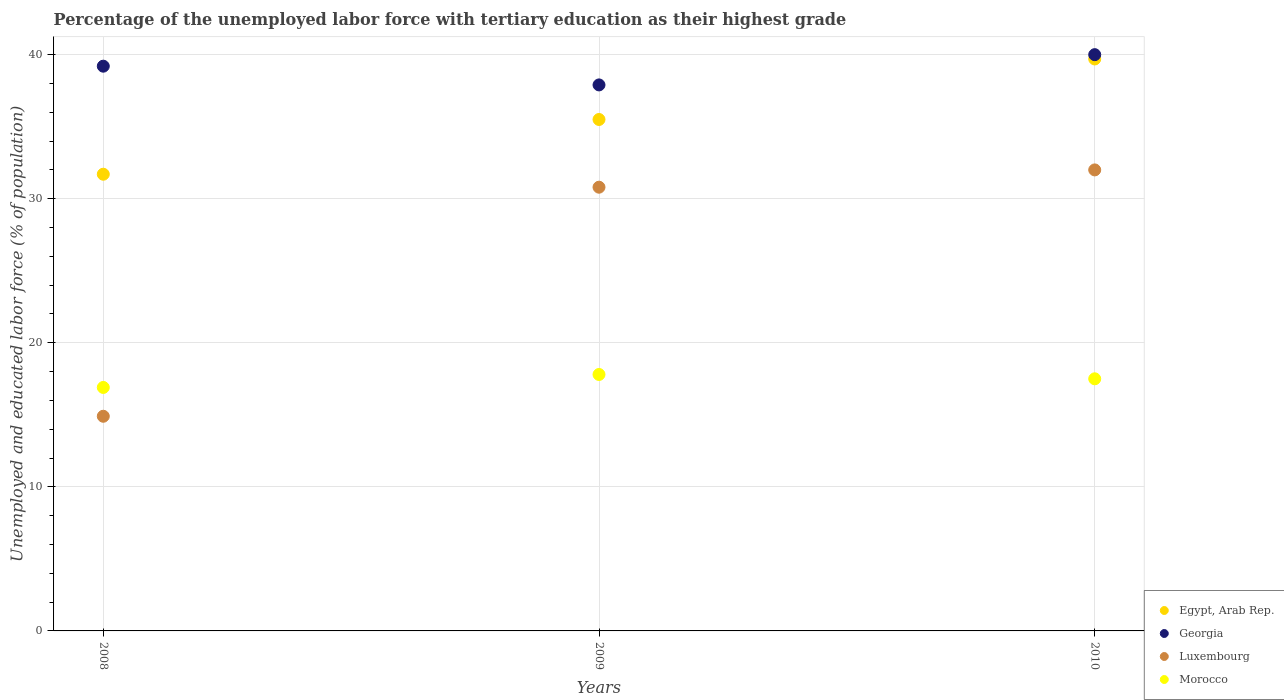Is the number of dotlines equal to the number of legend labels?
Offer a terse response. Yes. What is the percentage of the unemployed labor force with tertiary education in Egypt, Arab Rep. in 2009?
Your answer should be very brief. 35.5. Across all years, what is the maximum percentage of the unemployed labor force with tertiary education in Egypt, Arab Rep.?
Offer a very short reply. 39.7. Across all years, what is the minimum percentage of the unemployed labor force with tertiary education in Morocco?
Make the answer very short. 16.9. In which year was the percentage of the unemployed labor force with tertiary education in Morocco maximum?
Give a very brief answer. 2009. In which year was the percentage of the unemployed labor force with tertiary education in Morocco minimum?
Provide a short and direct response. 2008. What is the total percentage of the unemployed labor force with tertiary education in Luxembourg in the graph?
Provide a succinct answer. 77.7. What is the difference between the percentage of the unemployed labor force with tertiary education in Egypt, Arab Rep. in 2008 and that in 2010?
Give a very brief answer. -8. What is the difference between the percentage of the unemployed labor force with tertiary education in Georgia in 2008 and the percentage of the unemployed labor force with tertiary education in Morocco in 2010?
Offer a very short reply. 21.7. What is the average percentage of the unemployed labor force with tertiary education in Georgia per year?
Offer a very short reply. 39.03. In the year 2008, what is the difference between the percentage of the unemployed labor force with tertiary education in Morocco and percentage of the unemployed labor force with tertiary education in Egypt, Arab Rep.?
Make the answer very short. -14.8. In how many years, is the percentage of the unemployed labor force with tertiary education in Georgia greater than 32 %?
Your answer should be compact. 3. What is the ratio of the percentage of the unemployed labor force with tertiary education in Morocco in 2008 to that in 2009?
Your response must be concise. 0.95. Is the difference between the percentage of the unemployed labor force with tertiary education in Morocco in 2009 and 2010 greater than the difference between the percentage of the unemployed labor force with tertiary education in Egypt, Arab Rep. in 2009 and 2010?
Ensure brevity in your answer.  Yes. What is the difference between the highest and the second highest percentage of the unemployed labor force with tertiary education in Egypt, Arab Rep.?
Provide a succinct answer. 4.2. What is the difference between the highest and the lowest percentage of the unemployed labor force with tertiary education in Georgia?
Your answer should be compact. 2.1. In how many years, is the percentage of the unemployed labor force with tertiary education in Egypt, Arab Rep. greater than the average percentage of the unemployed labor force with tertiary education in Egypt, Arab Rep. taken over all years?
Your response must be concise. 1. Is the sum of the percentage of the unemployed labor force with tertiary education in Morocco in 2008 and 2010 greater than the maximum percentage of the unemployed labor force with tertiary education in Egypt, Arab Rep. across all years?
Your answer should be compact. No. Is it the case that in every year, the sum of the percentage of the unemployed labor force with tertiary education in Georgia and percentage of the unemployed labor force with tertiary education in Luxembourg  is greater than the sum of percentage of the unemployed labor force with tertiary education in Morocco and percentage of the unemployed labor force with tertiary education in Egypt, Arab Rep.?
Keep it short and to the point. No. Is it the case that in every year, the sum of the percentage of the unemployed labor force with tertiary education in Morocco and percentage of the unemployed labor force with tertiary education in Luxembourg  is greater than the percentage of the unemployed labor force with tertiary education in Georgia?
Your answer should be compact. No. Does the percentage of the unemployed labor force with tertiary education in Georgia monotonically increase over the years?
Provide a succinct answer. No. How many dotlines are there?
Provide a succinct answer. 4. How many years are there in the graph?
Offer a very short reply. 3. Does the graph contain any zero values?
Keep it short and to the point. No. Does the graph contain grids?
Provide a short and direct response. Yes. What is the title of the graph?
Make the answer very short. Percentage of the unemployed labor force with tertiary education as their highest grade. Does "Latvia" appear as one of the legend labels in the graph?
Give a very brief answer. No. What is the label or title of the X-axis?
Make the answer very short. Years. What is the label or title of the Y-axis?
Your answer should be compact. Unemployed and educated labor force (% of population). What is the Unemployed and educated labor force (% of population) of Egypt, Arab Rep. in 2008?
Give a very brief answer. 31.7. What is the Unemployed and educated labor force (% of population) in Georgia in 2008?
Your answer should be very brief. 39.2. What is the Unemployed and educated labor force (% of population) in Luxembourg in 2008?
Your response must be concise. 14.9. What is the Unemployed and educated labor force (% of population) of Morocco in 2008?
Provide a short and direct response. 16.9. What is the Unemployed and educated labor force (% of population) in Egypt, Arab Rep. in 2009?
Provide a short and direct response. 35.5. What is the Unemployed and educated labor force (% of population) of Georgia in 2009?
Provide a succinct answer. 37.9. What is the Unemployed and educated labor force (% of population) of Luxembourg in 2009?
Offer a very short reply. 30.8. What is the Unemployed and educated labor force (% of population) in Morocco in 2009?
Provide a short and direct response. 17.8. What is the Unemployed and educated labor force (% of population) of Egypt, Arab Rep. in 2010?
Your answer should be very brief. 39.7. Across all years, what is the maximum Unemployed and educated labor force (% of population) in Egypt, Arab Rep.?
Keep it short and to the point. 39.7. Across all years, what is the maximum Unemployed and educated labor force (% of population) of Luxembourg?
Provide a short and direct response. 32. Across all years, what is the maximum Unemployed and educated labor force (% of population) in Morocco?
Make the answer very short. 17.8. Across all years, what is the minimum Unemployed and educated labor force (% of population) of Egypt, Arab Rep.?
Give a very brief answer. 31.7. Across all years, what is the minimum Unemployed and educated labor force (% of population) in Georgia?
Ensure brevity in your answer.  37.9. Across all years, what is the minimum Unemployed and educated labor force (% of population) of Luxembourg?
Ensure brevity in your answer.  14.9. Across all years, what is the minimum Unemployed and educated labor force (% of population) of Morocco?
Make the answer very short. 16.9. What is the total Unemployed and educated labor force (% of population) in Egypt, Arab Rep. in the graph?
Make the answer very short. 106.9. What is the total Unemployed and educated labor force (% of population) of Georgia in the graph?
Give a very brief answer. 117.1. What is the total Unemployed and educated labor force (% of population) of Luxembourg in the graph?
Provide a succinct answer. 77.7. What is the total Unemployed and educated labor force (% of population) in Morocco in the graph?
Provide a succinct answer. 52.2. What is the difference between the Unemployed and educated labor force (% of population) of Luxembourg in 2008 and that in 2009?
Offer a very short reply. -15.9. What is the difference between the Unemployed and educated labor force (% of population) in Luxembourg in 2008 and that in 2010?
Your response must be concise. -17.1. What is the difference between the Unemployed and educated labor force (% of population) of Morocco in 2008 and that in 2010?
Your answer should be compact. -0.6. What is the difference between the Unemployed and educated labor force (% of population) in Morocco in 2009 and that in 2010?
Provide a short and direct response. 0.3. What is the difference between the Unemployed and educated labor force (% of population) of Georgia in 2008 and the Unemployed and educated labor force (% of population) of Morocco in 2009?
Provide a short and direct response. 21.4. What is the difference between the Unemployed and educated labor force (% of population) of Luxembourg in 2008 and the Unemployed and educated labor force (% of population) of Morocco in 2009?
Ensure brevity in your answer.  -2.9. What is the difference between the Unemployed and educated labor force (% of population) in Egypt, Arab Rep. in 2008 and the Unemployed and educated labor force (% of population) in Luxembourg in 2010?
Your answer should be very brief. -0.3. What is the difference between the Unemployed and educated labor force (% of population) in Egypt, Arab Rep. in 2008 and the Unemployed and educated labor force (% of population) in Morocco in 2010?
Ensure brevity in your answer.  14.2. What is the difference between the Unemployed and educated labor force (% of population) in Georgia in 2008 and the Unemployed and educated labor force (% of population) in Luxembourg in 2010?
Keep it short and to the point. 7.2. What is the difference between the Unemployed and educated labor force (% of population) of Georgia in 2008 and the Unemployed and educated labor force (% of population) of Morocco in 2010?
Provide a short and direct response. 21.7. What is the difference between the Unemployed and educated labor force (% of population) in Luxembourg in 2008 and the Unemployed and educated labor force (% of population) in Morocco in 2010?
Your answer should be very brief. -2.6. What is the difference between the Unemployed and educated labor force (% of population) of Egypt, Arab Rep. in 2009 and the Unemployed and educated labor force (% of population) of Georgia in 2010?
Ensure brevity in your answer.  -4.5. What is the difference between the Unemployed and educated labor force (% of population) of Georgia in 2009 and the Unemployed and educated labor force (% of population) of Morocco in 2010?
Ensure brevity in your answer.  20.4. What is the average Unemployed and educated labor force (% of population) in Egypt, Arab Rep. per year?
Make the answer very short. 35.63. What is the average Unemployed and educated labor force (% of population) in Georgia per year?
Keep it short and to the point. 39.03. What is the average Unemployed and educated labor force (% of population) in Luxembourg per year?
Your answer should be very brief. 25.9. In the year 2008, what is the difference between the Unemployed and educated labor force (% of population) in Egypt, Arab Rep. and Unemployed and educated labor force (% of population) in Luxembourg?
Provide a succinct answer. 16.8. In the year 2008, what is the difference between the Unemployed and educated labor force (% of population) in Georgia and Unemployed and educated labor force (% of population) in Luxembourg?
Ensure brevity in your answer.  24.3. In the year 2008, what is the difference between the Unemployed and educated labor force (% of population) in Georgia and Unemployed and educated labor force (% of population) in Morocco?
Ensure brevity in your answer.  22.3. In the year 2009, what is the difference between the Unemployed and educated labor force (% of population) in Egypt, Arab Rep. and Unemployed and educated labor force (% of population) in Georgia?
Provide a succinct answer. -2.4. In the year 2009, what is the difference between the Unemployed and educated labor force (% of population) in Egypt, Arab Rep. and Unemployed and educated labor force (% of population) in Luxembourg?
Offer a terse response. 4.7. In the year 2009, what is the difference between the Unemployed and educated labor force (% of population) of Egypt, Arab Rep. and Unemployed and educated labor force (% of population) of Morocco?
Keep it short and to the point. 17.7. In the year 2009, what is the difference between the Unemployed and educated labor force (% of population) in Georgia and Unemployed and educated labor force (% of population) in Morocco?
Your answer should be very brief. 20.1. In the year 2010, what is the difference between the Unemployed and educated labor force (% of population) in Egypt, Arab Rep. and Unemployed and educated labor force (% of population) in Georgia?
Ensure brevity in your answer.  -0.3. In the year 2010, what is the difference between the Unemployed and educated labor force (% of population) in Egypt, Arab Rep. and Unemployed and educated labor force (% of population) in Luxembourg?
Offer a very short reply. 7.7. In the year 2010, what is the difference between the Unemployed and educated labor force (% of population) of Egypt, Arab Rep. and Unemployed and educated labor force (% of population) of Morocco?
Give a very brief answer. 22.2. In the year 2010, what is the difference between the Unemployed and educated labor force (% of population) in Georgia and Unemployed and educated labor force (% of population) in Luxembourg?
Your answer should be compact. 8. What is the ratio of the Unemployed and educated labor force (% of population) in Egypt, Arab Rep. in 2008 to that in 2009?
Ensure brevity in your answer.  0.89. What is the ratio of the Unemployed and educated labor force (% of population) of Georgia in 2008 to that in 2009?
Your answer should be very brief. 1.03. What is the ratio of the Unemployed and educated labor force (% of population) in Luxembourg in 2008 to that in 2009?
Give a very brief answer. 0.48. What is the ratio of the Unemployed and educated labor force (% of population) of Morocco in 2008 to that in 2009?
Your response must be concise. 0.95. What is the ratio of the Unemployed and educated labor force (% of population) of Egypt, Arab Rep. in 2008 to that in 2010?
Offer a very short reply. 0.8. What is the ratio of the Unemployed and educated labor force (% of population) of Georgia in 2008 to that in 2010?
Make the answer very short. 0.98. What is the ratio of the Unemployed and educated labor force (% of population) in Luxembourg in 2008 to that in 2010?
Provide a succinct answer. 0.47. What is the ratio of the Unemployed and educated labor force (% of population) of Morocco in 2008 to that in 2010?
Keep it short and to the point. 0.97. What is the ratio of the Unemployed and educated labor force (% of population) in Egypt, Arab Rep. in 2009 to that in 2010?
Your response must be concise. 0.89. What is the ratio of the Unemployed and educated labor force (% of population) in Georgia in 2009 to that in 2010?
Provide a succinct answer. 0.95. What is the ratio of the Unemployed and educated labor force (% of population) in Luxembourg in 2009 to that in 2010?
Your answer should be compact. 0.96. What is the ratio of the Unemployed and educated labor force (% of population) of Morocco in 2009 to that in 2010?
Provide a short and direct response. 1.02. What is the difference between the highest and the second highest Unemployed and educated labor force (% of population) of Georgia?
Keep it short and to the point. 0.8. What is the difference between the highest and the second highest Unemployed and educated labor force (% of population) of Morocco?
Offer a terse response. 0.3. What is the difference between the highest and the lowest Unemployed and educated labor force (% of population) in Egypt, Arab Rep.?
Provide a short and direct response. 8. What is the difference between the highest and the lowest Unemployed and educated labor force (% of population) of Luxembourg?
Provide a short and direct response. 17.1. What is the difference between the highest and the lowest Unemployed and educated labor force (% of population) of Morocco?
Your answer should be very brief. 0.9. 